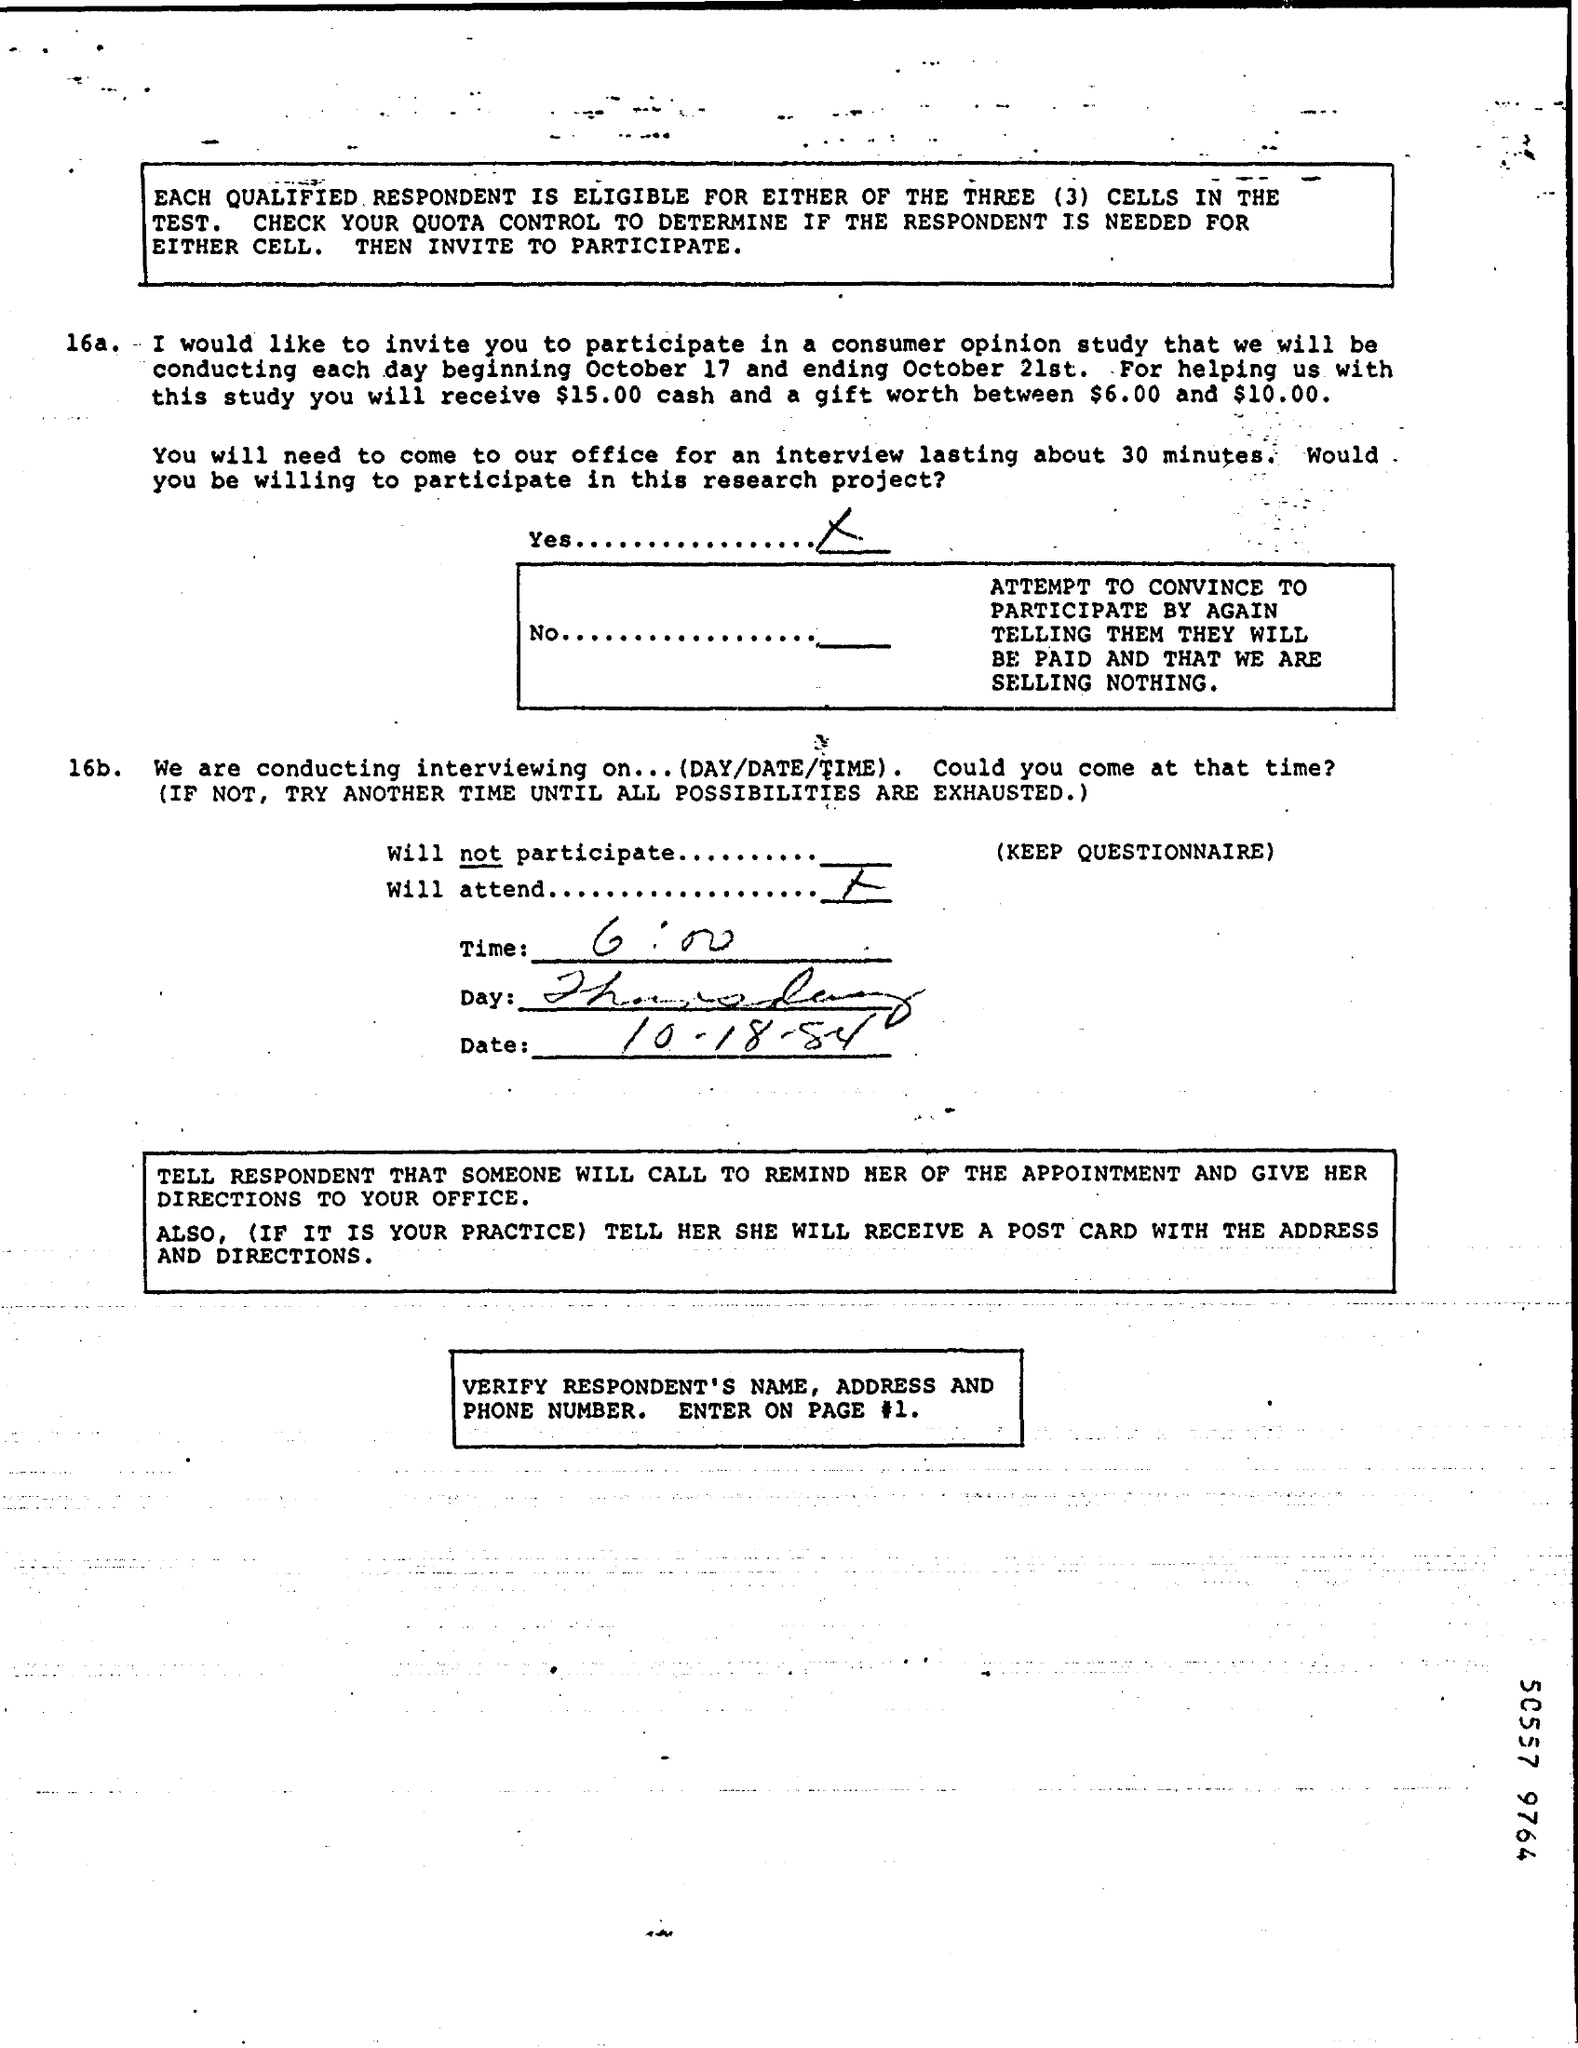Point out several critical features in this image. The document contains Thursday. The time mentioned in the document is 6:00. The date mentioned in the document is 10.18.84. The number 50557 is located at the bottom. 